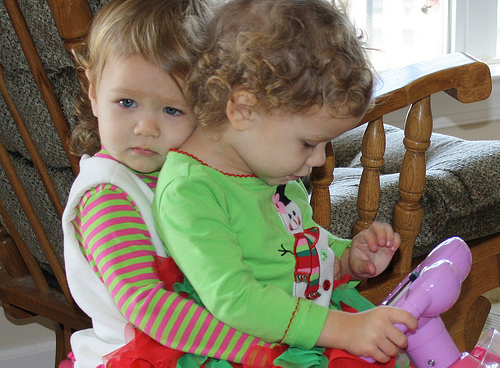<image>
Can you confirm if the child is to the left of the child? Yes. From this viewpoint, the child is positioned to the left side relative to the child. 